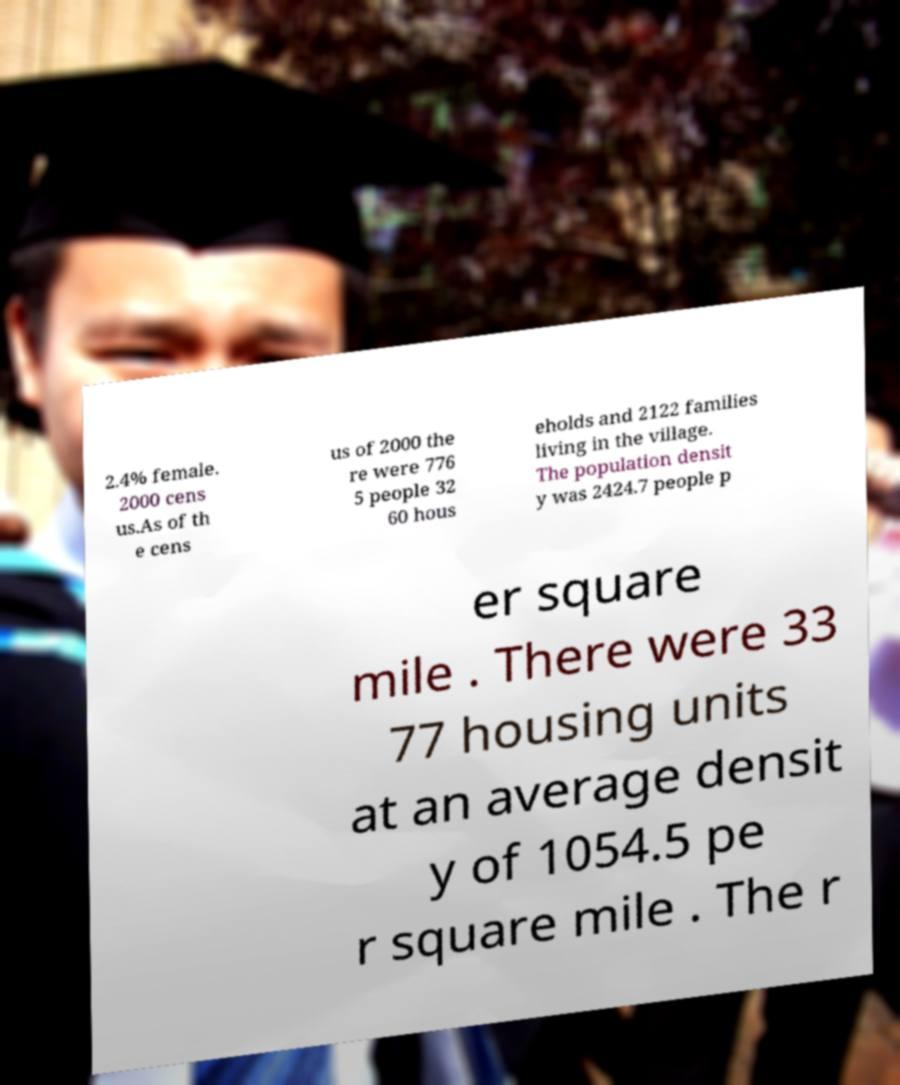There's text embedded in this image that I need extracted. Can you transcribe it verbatim? 2.4% female. 2000 cens us.As of th e cens us of 2000 the re were 776 5 people 32 60 hous eholds and 2122 families living in the village. The population densit y was 2424.7 people p er square mile . There were 33 77 housing units at an average densit y of 1054.5 pe r square mile . The r 